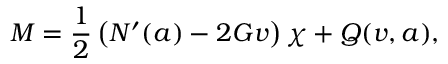<formula> <loc_0><loc_0><loc_500><loc_500>M = \frac { 1 } { 2 } \left ( N ^ { \prime } ( a ) - 2 G v \right ) \chi + Q ( v , a ) ,</formula> 